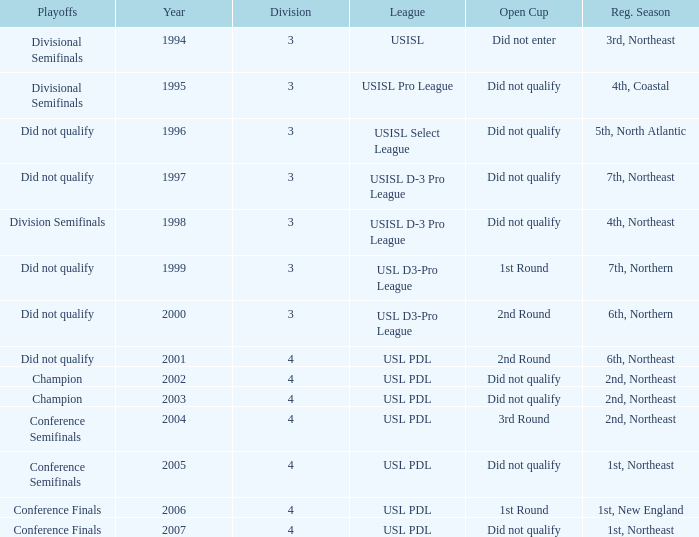Mame the reg season for 2001 6th, Northeast. Give me the full table as a dictionary. {'header': ['Playoffs', 'Year', 'Division', 'League', 'Open Cup', 'Reg. Season'], 'rows': [['Divisional Semifinals', '1994', '3', 'USISL', 'Did not enter', '3rd, Northeast'], ['Divisional Semifinals', '1995', '3', 'USISL Pro League', 'Did not qualify', '4th, Coastal'], ['Did not qualify', '1996', '3', 'USISL Select League', 'Did not qualify', '5th, North Atlantic'], ['Did not qualify', '1997', '3', 'USISL D-3 Pro League', 'Did not qualify', '7th, Northeast'], ['Division Semifinals', '1998', '3', 'USISL D-3 Pro League', 'Did not qualify', '4th, Northeast'], ['Did not qualify', '1999', '3', 'USL D3-Pro League', '1st Round', '7th, Northern'], ['Did not qualify', '2000', '3', 'USL D3-Pro League', '2nd Round', '6th, Northern'], ['Did not qualify', '2001', '4', 'USL PDL', '2nd Round', '6th, Northeast'], ['Champion', '2002', '4', 'USL PDL', 'Did not qualify', '2nd, Northeast'], ['Champion', '2003', '4', 'USL PDL', 'Did not qualify', '2nd, Northeast'], ['Conference Semifinals', '2004', '4', 'USL PDL', '3rd Round', '2nd, Northeast'], ['Conference Semifinals', '2005', '4', 'USL PDL', 'Did not qualify', '1st, Northeast'], ['Conference Finals', '2006', '4', 'USL PDL', '1st Round', '1st, New England'], ['Conference Finals', '2007', '4', 'USL PDL', 'Did not qualify', '1st, Northeast']]} 